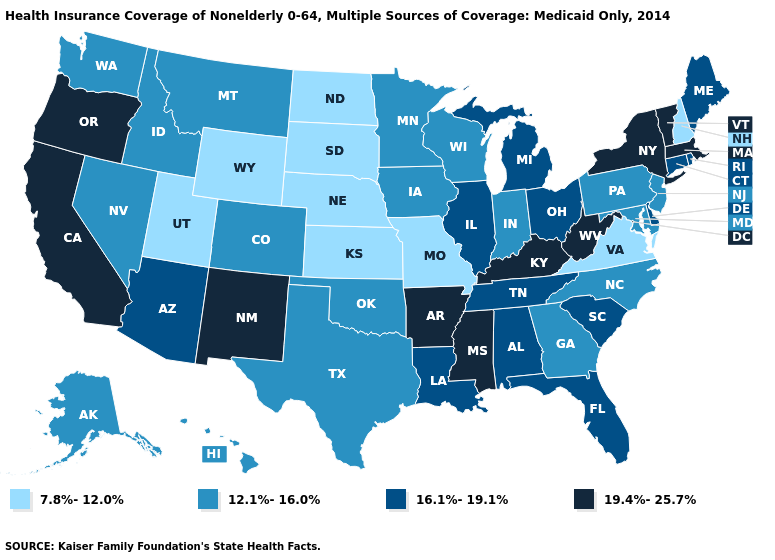Name the states that have a value in the range 12.1%-16.0%?
Write a very short answer. Alaska, Colorado, Georgia, Hawaii, Idaho, Indiana, Iowa, Maryland, Minnesota, Montana, Nevada, New Jersey, North Carolina, Oklahoma, Pennsylvania, Texas, Washington, Wisconsin. Name the states that have a value in the range 12.1%-16.0%?
Concise answer only. Alaska, Colorado, Georgia, Hawaii, Idaho, Indiana, Iowa, Maryland, Minnesota, Montana, Nevada, New Jersey, North Carolina, Oklahoma, Pennsylvania, Texas, Washington, Wisconsin. Does Wyoming have a lower value than Rhode Island?
Short answer required. Yes. Name the states that have a value in the range 7.8%-12.0%?
Answer briefly. Kansas, Missouri, Nebraska, New Hampshire, North Dakota, South Dakota, Utah, Virginia, Wyoming. Does Pennsylvania have the same value as North Dakota?
Be succinct. No. Does Wyoming have the lowest value in the USA?
Answer briefly. Yes. What is the value of Louisiana?
Write a very short answer. 16.1%-19.1%. Which states have the lowest value in the South?
Answer briefly. Virginia. Does Oregon have a lower value than Arizona?
Be succinct. No. Does Tennessee have a lower value than West Virginia?
Be succinct. Yes. Among the states that border New Mexico , does Utah have the lowest value?
Write a very short answer. Yes. What is the value of Illinois?
Concise answer only. 16.1%-19.1%. What is the value of Arkansas?
Quick response, please. 19.4%-25.7%. Name the states that have a value in the range 12.1%-16.0%?
Concise answer only. Alaska, Colorado, Georgia, Hawaii, Idaho, Indiana, Iowa, Maryland, Minnesota, Montana, Nevada, New Jersey, North Carolina, Oklahoma, Pennsylvania, Texas, Washington, Wisconsin. Which states have the lowest value in the West?
Write a very short answer. Utah, Wyoming. 